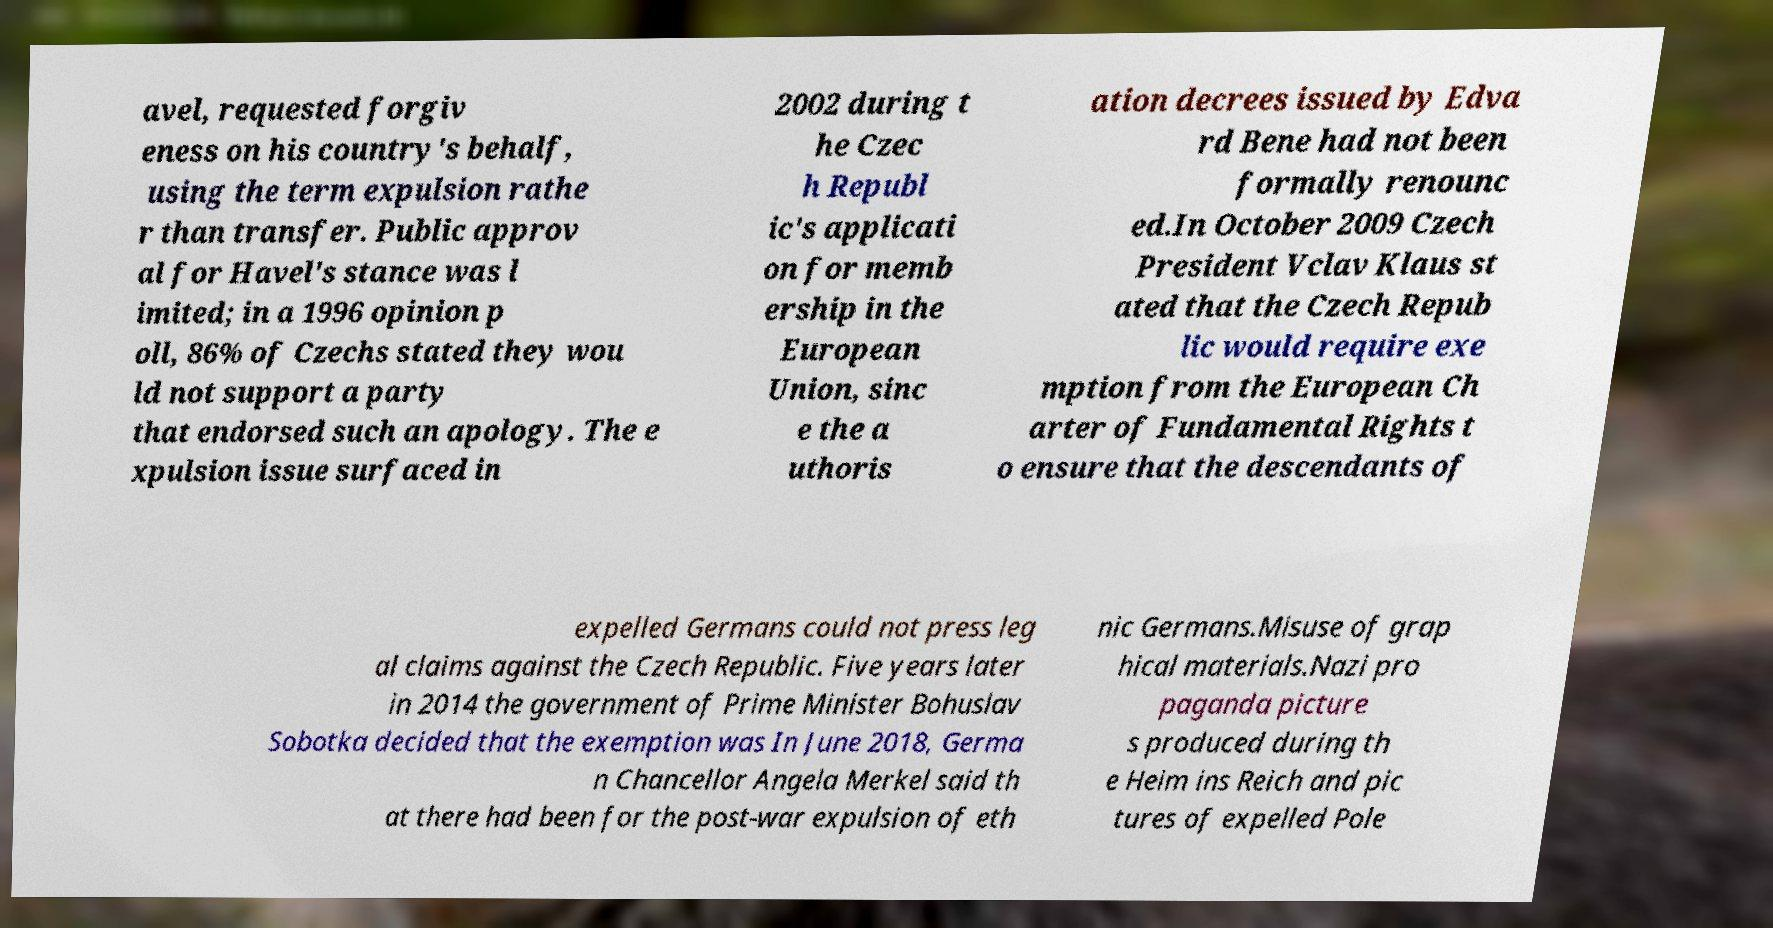Could you extract and type out the text from this image? avel, requested forgiv eness on his country's behalf, using the term expulsion rathe r than transfer. Public approv al for Havel's stance was l imited; in a 1996 opinion p oll, 86% of Czechs stated they wou ld not support a party that endorsed such an apology. The e xpulsion issue surfaced in 2002 during t he Czec h Republ ic's applicati on for memb ership in the European Union, sinc e the a uthoris ation decrees issued by Edva rd Bene had not been formally renounc ed.In October 2009 Czech President Vclav Klaus st ated that the Czech Repub lic would require exe mption from the European Ch arter of Fundamental Rights t o ensure that the descendants of expelled Germans could not press leg al claims against the Czech Republic. Five years later in 2014 the government of Prime Minister Bohuslav Sobotka decided that the exemption was In June 2018, Germa n Chancellor Angela Merkel said th at there had been for the post-war expulsion of eth nic Germans.Misuse of grap hical materials.Nazi pro paganda picture s produced during th e Heim ins Reich and pic tures of expelled Pole 